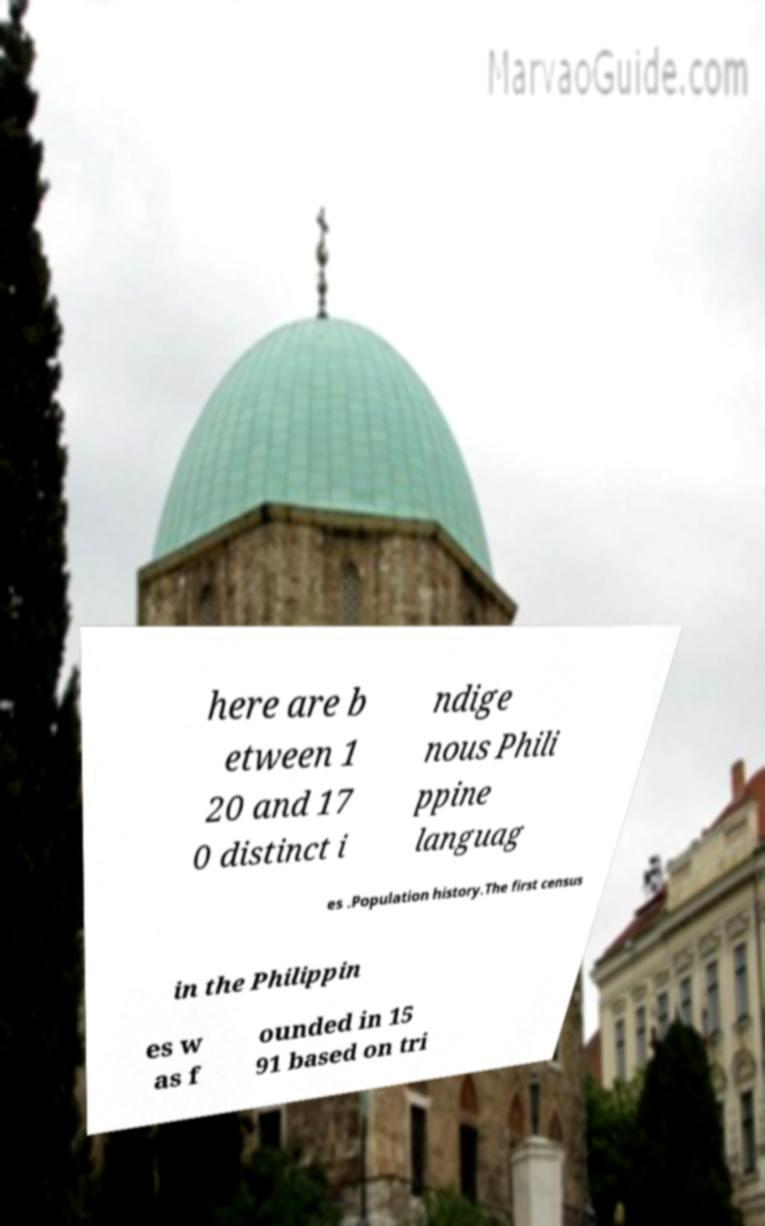Please identify and transcribe the text found in this image. here are b etween 1 20 and 17 0 distinct i ndige nous Phili ppine languag es .Population history.The first census in the Philippin es w as f ounded in 15 91 based on tri 